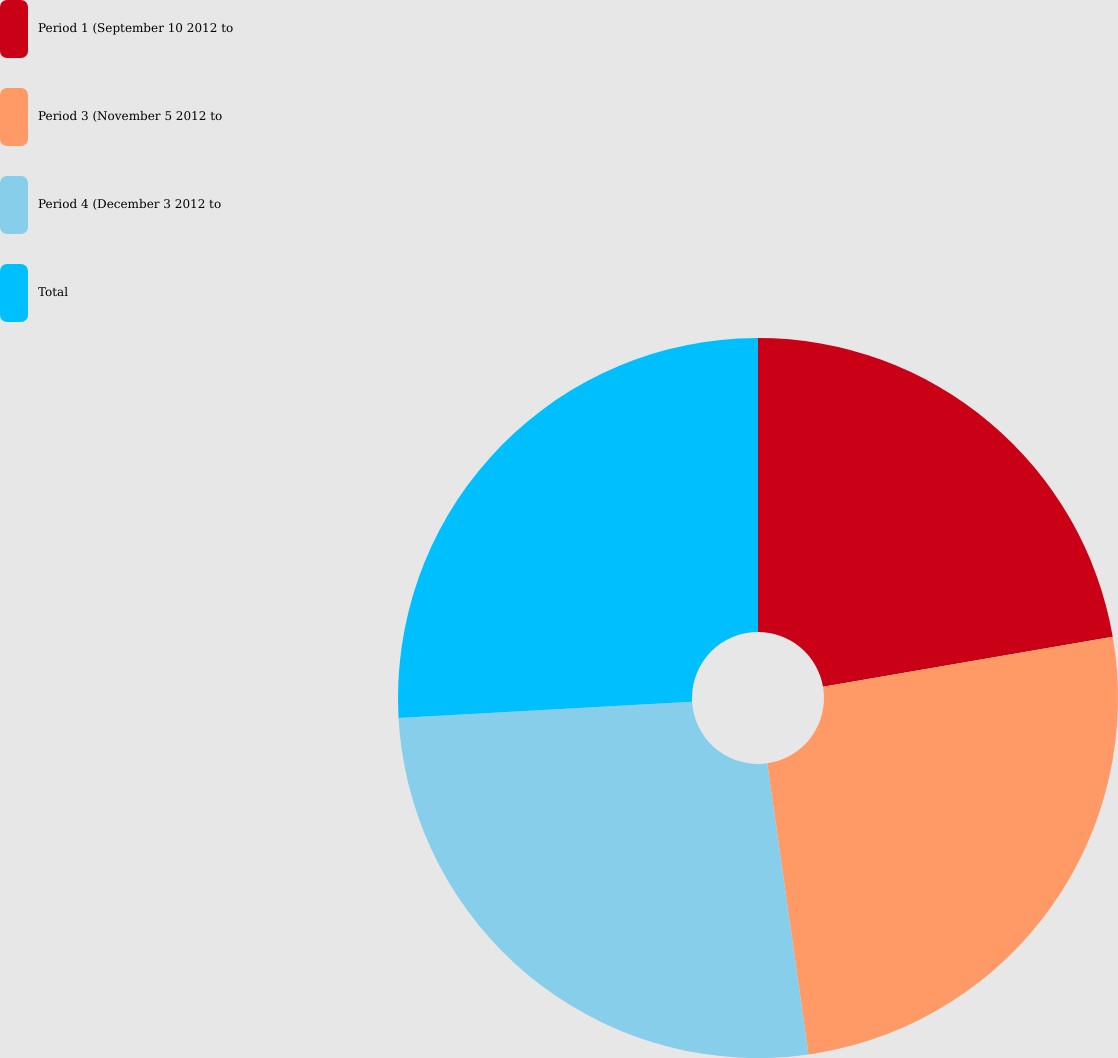<chart> <loc_0><loc_0><loc_500><loc_500><pie_chart><fcel>Period 1 (September 10 2012 to<fcel>Period 3 (November 5 2012 to<fcel>Period 4 (December 3 2012 to<fcel>Total<nl><fcel>22.28%<fcel>25.48%<fcel>26.36%<fcel>25.88%<nl></chart> 